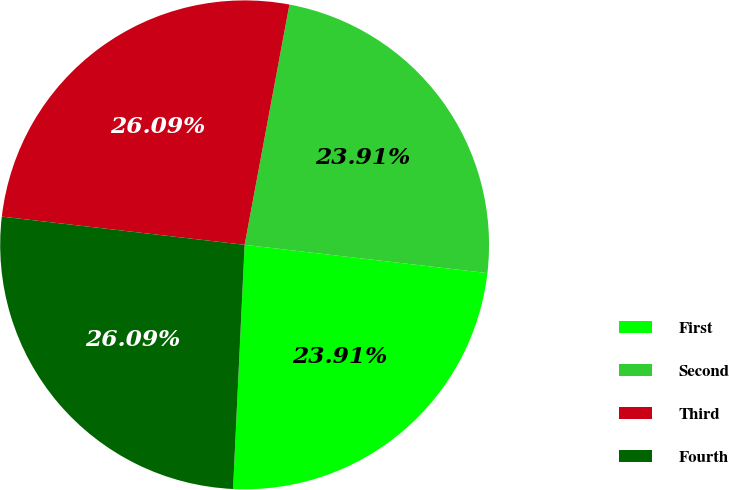<chart> <loc_0><loc_0><loc_500><loc_500><pie_chart><fcel>First<fcel>Second<fcel>Third<fcel>Fourth<nl><fcel>23.91%<fcel>23.91%<fcel>26.09%<fcel>26.09%<nl></chart> 